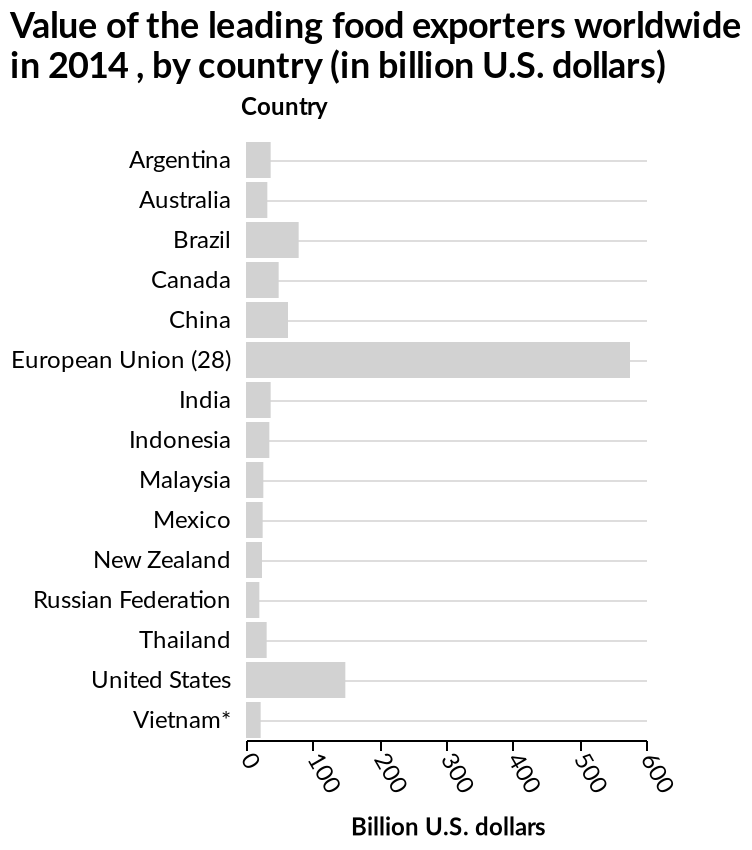<image>
please describe the details of the chart Here a bar diagram is named Value of the leading food exporters worldwide in 2014 , by country (in billion U.S. dollars). A categorical scale starting at Argentina and ending at Vietnam* can be found along the y-axis, labeled Country. Billion U.S. dollars is defined along a linear scale of range 0 to 600 along the x-axis. Which two countries had the lowest food exports in 2014?  The Russian Federation and Vietnam had the lowest food exports in 2014, with around 15 billion dollars. What was the difference in food exports between the European Union and the Russian Federation/Vietnam in 2014? The difference in food exports between the European Union and the Russian Federation/Vietnam in 2014 was around 535 billion dollars. 